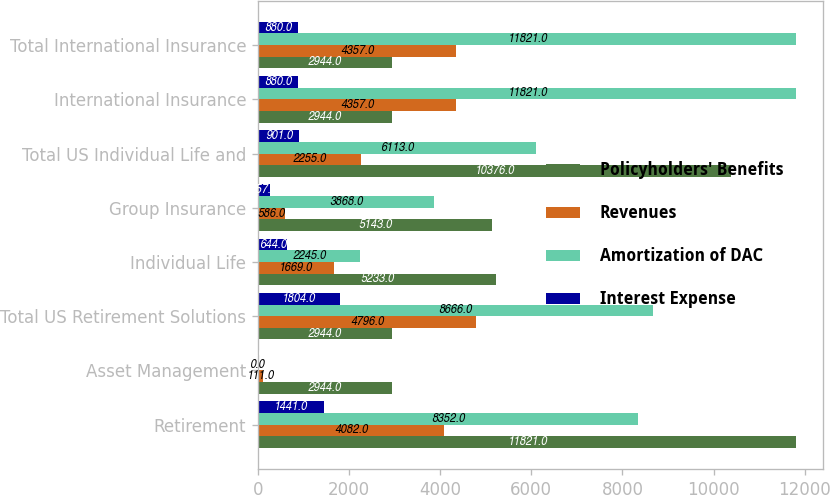<chart> <loc_0><loc_0><loc_500><loc_500><stacked_bar_chart><ecel><fcel>Retirement<fcel>Asset Management<fcel>Total US Retirement Solutions<fcel>Individual Life<fcel>Group Insurance<fcel>Total US Individual Life and<fcel>International Insurance<fcel>Total International Insurance<nl><fcel>Policyholders' Benefits<fcel>11821<fcel>2944<fcel>2944<fcel>5233<fcel>5143<fcel>10376<fcel>2944<fcel>2944<nl><fcel>Revenues<fcel>4082<fcel>111<fcel>4796<fcel>1669<fcel>586<fcel>2255<fcel>4357<fcel>4357<nl><fcel>Amortization of DAC<fcel>8352<fcel>0<fcel>8666<fcel>2245<fcel>3868<fcel>6113<fcel>11821<fcel>11821<nl><fcel>Interest Expense<fcel>1441<fcel>0<fcel>1804<fcel>644<fcel>257<fcel>901<fcel>880<fcel>880<nl></chart> 